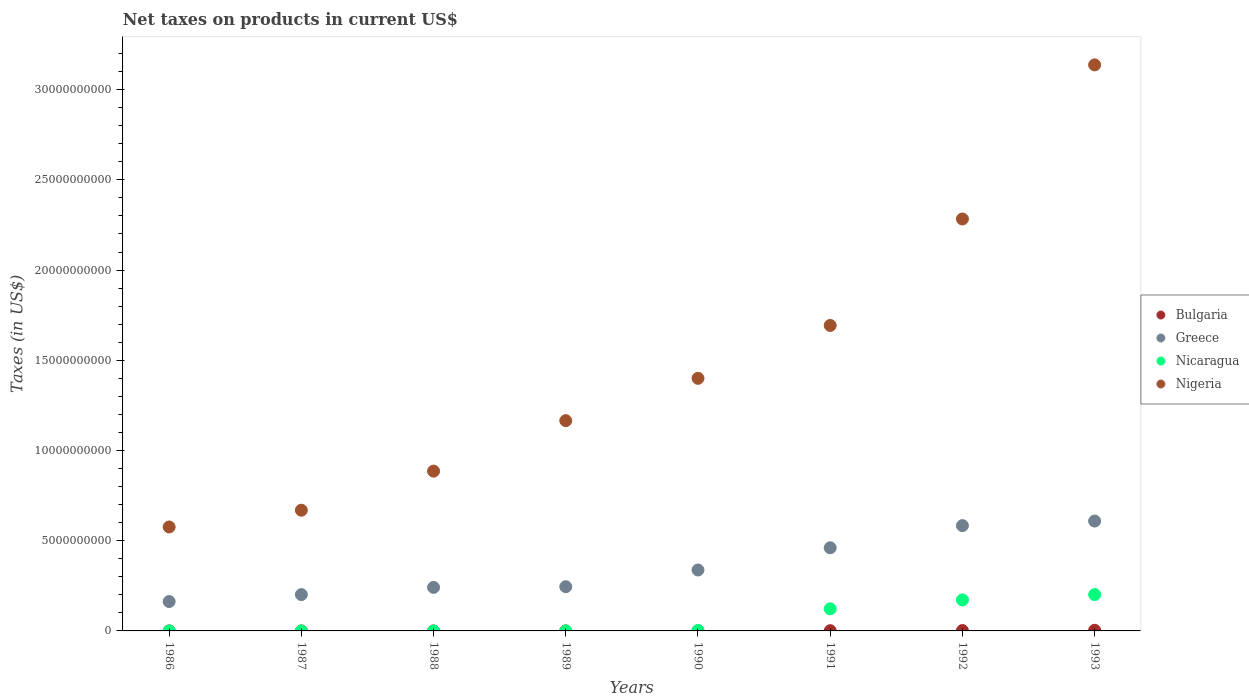How many different coloured dotlines are there?
Offer a terse response. 4. What is the net taxes on products in Nicaragua in 1991?
Provide a short and direct response. 1.23e+09. Across all years, what is the maximum net taxes on products in Nigeria?
Your response must be concise. 3.14e+1. Across all years, what is the minimum net taxes on products in Nigeria?
Offer a terse response. 5.76e+09. In which year was the net taxes on products in Greece maximum?
Your answer should be very brief. 1993. What is the total net taxes on products in Greece in the graph?
Provide a short and direct response. 2.84e+1. What is the difference between the net taxes on products in Nigeria in 1986 and that in 1993?
Give a very brief answer. -2.56e+1. What is the difference between the net taxes on products in Bulgaria in 1993 and the net taxes on products in Nicaragua in 1986?
Your answer should be compact. 3.62e+07. What is the average net taxes on products in Bulgaria per year?
Make the answer very short. 8.72e+06. In the year 1988, what is the difference between the net taxes on products in Nicaragua and net taxes on products in Nigeria?
Your answer should be compact. -8.86e+09. In how many years, is the net taxes on products in Greece greater than 5000000000 US$?
Your answer should be compact. 2. What is the ratio of the net taxes on products in Nigeria in 1988 to that in 1991?
Your answer should be compact. 0.52. Is the net taxes on products in Nigeria in 1988 less than that in 1989?
Give a very brief answer. Yes. Is the difference between the net taxes on products in Nicaragua in 1989 and 1990 greater than the difference between the net taxes on products in Nigeria in 1989 and 1990?
Offer a very short reply. Yes. What is the difference between the highest and the second highest net taxes on products in Greece?
Give a very brief answer. 2.54e+08. What is the difference between the highest and the lowest net taxes on products in Bulgaria?
Your answer should be compact. 3.62e+07. Is it the case that in every year, the sum of the net taxes on products in Nicaragua and net taxes on products in Nigeria  is greater than the net taxes on products in Bulgaria?
Provide a short and direct response. Yes. Is the net taxes on products in Bulgaria strictly greater than the net taxes on products in Nigeria over the years?
Your response must be concise. No. Is the net taxes on products in Nigeria strictly less than the net taxes on products in Nicaragua over the years?
Make the answer very short. No. How many years are there in the graph?
Keep it short and to the point. 8. Are the values on the major ticks of Y-axis written in scientific E-notation?
Keep it short and to the point. No. Does the graph contain grids?
Give a very brief answer. No. How many legend labels are there?
Your answer should be very brief. 4. What is the title of the graph?
Provide a short and direct response. Net taxes on products in current US$. What is the label or title of the X-axis?
Give a very brief answer. Years. What is the label or title of the Y-axis?
Offer a terse response. Taxes (in US$). What is the Taxes (in US$) of Bulgaria in 1986?
Your answer should be very brief. 5.85e+05. What is the Taxes (in US$) in Greece in 1986?
Offer a very short reply. 1.63e+09. What is the Taxes (in US$) of Nicaragua in 1986?
Give a very brief answer. 18.95. What is the Taxes (in US$) of Nigeria in 1986?
Give a very brief answer. 5.76e+09. What is the Taxes (in US$) in Bulgaria in 1987?
Offer a terse response. 0. What is the Taxes (in US$) in Greece in 1987?
Make the answer very short. 2.01e+09. What is the Taxes (in US$) in Nicaragua in 1987?
Keep it short and to the point. 99.43. What is the Taxes (in US$) in Nigeria in 1987?
Make the answer very short. 6.69e+09. What is the Taxes (in US$) in Bulgaria in 1988?
Your response must be concise. 0. What is the Taxes (in US$) in Greece in 1988?
Provide a short and direct response. 2.41e+09. What is the Taxes (in US$) of Nicaragua in 1988?
Your answer should be very brief. 5343.08. What is the Taxes (in US$) in Nigeria in 1988?
Your answer should be very brief. 8.86e+09. What is the Taxes (in US$) of Greece in 1989?
Offer a terse response. 2.45e+09. What is the Taxes (in US$) of Nicaragua in 1989?
Your answer should be compact. 4.98e+05. What is the Taxes (in US$) in Nigeria in 1989?
Your answer should be very brief. 1.17e+1. What is the Taxes (in US$) in Greece in 1990?
Provide a short and direct response. 3.38e+09. What is the Taxes (in US$) in Nicaragua in 1990?
Provide a short and direct response. 2.35e+07. What is the Taxes (in US$) in Nigeria in 1990?
Your answer should be compact. 1.40e+1. What is the Taxes (in US$) of Bulgaria in 1991?
Your response must be concise. 1.24e+07. What is the Taxes (in US$) of Greece in 1991?
Your answer should be very brief. 4.61e+09. What is the Taxes (in US$) in Nicaragua in 1991?
Offer a very short reply. 1.23e+09. What is the Taxes (in US$) in Nigeria in 1991?
Offer a terse response. 1.69e+1. What is the Taxes (in US$) of Bulgaria in 1992?
Make the answer very short. 2.05e+07. What is the Taxes (in US$) of Greece in 1992?
Give a very brief answer. 5.84e+09. What is the Taxes (in US$) in Nicaragua in 1992?
Ensure brevity in your answer.  1.72e+09. What is the Taxes (in US$) in Nigeria in 1992?
Ensure brevity in your answer.  2.28e+1. What is the Taxes (in US$) in Bulgaria in 1993?
Your answer should be compact. 3.62e+07. What is the Taxes (in US$) in Greece in 1993?
Keep it short and to the point. 6.09e+09. What is the Taxes (in US$) in Nicaragua in 1993?
Ensure brevity in your answer.  2.01e+09. What is the Taxes (in US$) of Nigeria in 1993?
Offer a very short reply. 3.14e+1. Across all years, what is the maximum Taxes (in US$) of Bulgaria?
Offer a very short reply. 3.62e+07. Across all years, what is the maximum Taxes (in US$) of Greece?
Offer a very short reply. 6.09e+09. Across all years, what is the maximum Taxes (in US$) in Nicaragua?
Keep it short and to the point. 2.01e+09. Across all years, what is the maximum Taxes (in US$) of Nigeria?
Offer a terse response. 3.14e+1. Across all years, what is the minimum Taxes (in US$) of Greece?
Provide a succinct answer. 1.63e+09. Across all years, what is the minimum Taxes (in US$) of Nicaragua?
Keep it short and to the point. 18.95. Across all years, what is the minimum Taxes (in US$) in Nigeria?
Your response must be concise. 5.76e+09. What is the total Taxes (in US$) in Bulgaria in the graph?
Your answer should be compact. 6.97e+07. What is the total Taxes (in US$) in Greece in the graph?
Your answer should be very brief. 2.84e+1. What is the total Taxes (in US$) of Nicaragua in the graph?
Provide a short and direct response. 4.98e+09. What is the total Taxes (in US$) in Nigeria in the graph?
Make the answer very short. 1.18e+11. What is the difference between the Taxes (in US$) of Greece in 1986 and that in 1987?
Provide a succinct answer. -3.85e+08. What is the difference between the Taxes (in US$) of Nicaragua in 1986 and that in 1987?
Your answer should be compact. -80.48. What is the difference between the Taxes (in US$) of Nigeria in 1986 and that in 1987?
Your answer should be compact. -9.29e+08. What is the difference between the Taxes (in US$) in Greece in 1986 and that in 1988?
Offer a terse response. -7.85e+08. What is the difference between the Taxes (in US$) of Nicaragua in 1986 and that in 1988?
Your answer should be compact. -5324.13. What is the difference between the Taxes (in US$) of Nigeria in 1986 and that in 1988?
Keep it short and to the point. -3.09e+09. What is the difference between the Taxes (in US$) of Greece in 1986 and that in 1989?
Provide a succinct answer. -8.23e+08. What is the difference between the Taxes (in US$) of Nicaragua in 1986 and that in 1989?
Your answer should be very brief. -4.98e+05. What is the difference between the Taxes (in US$) of Nigeria in 1986 and that in 1989?
Offer a very short reply. -5.89e+09. What is the difference between the Taxes (in US$) in Greece in 1986 and that in 1990?
Keep it short and to the point. -1.75e+09. What is the difference between the Taxes (in US$) of Nicaragua in 1986 and that in 1990?
Make the answer very short. -2.35e+07. What is the difference between the Taxes (in US$) in Nigeria in 1986 and that in 1990?
Your answer should be compact. -8.24e+09. What is the difference between the Taxes (in US$) in Bulgaria in 1986 and that in 1991?
Give a very brief answer. -1.19e+07. What is the difference between the Taxes (in US$) of Greece in 1986 and that in 1991?
Ensure brevity in your answer.  -2.98e+09. What is the difference between the Taxes (in US$) of Nicaragua in 1986 and that in 1991?
Your response must be concise. -1.23e+09. What is the difference between the Taxes (in US$) of Nigeria in 1986 and that in 1991?
Keep it short and to the point. -1.12e+1. What is the difference between the Taxes (in US$) of Bulgaria in 1986 and that in 1992?
Keep it short and to the point. -1.99e+07. What is the difference between the Taxes (in US$) in Greece in 1986 and that in 1992?
Offer a terse response. -4.21e+09. What is the difference between the Taxes (in US$) in Nicaragua in 1986 and that in 1992?
Offer a very short reply. -1.72e+09. What is the difference between the Taxes (in US$) of Nigeria in 1986 and that in 1992?
Your response must be concise. -1.71e+1. What is the difference between the Taxes (in US$) in Bulgaria in 1986 and that in 1993?
Offer a terse response. -3.56e+07. What is the difference between the Taxes (in US$) of Greece in 1986 and that in 1993?
Make the answer very short. -4.46e+09. What is the difference between the Taxes (in US$) in Nicaragua in 1986 and that in 1993?
Offer a terse response. -2.01e+09. What is the difference between the Taxes (in US$) of Nigeria in 1986 and that in 1993?
Your answer should be compact. -2.56e+1. What is the difference between the Taxes (in US$) of Greece in 1987 and that in 1988?
Offer a terse response. -4.00e+08. What is the difference between the Taxes (in US$) of Nicaragua in 1987 and that in 1988?
Offer a terse response. -5243.65. What is the difference between the Taxes (in US$) in Nigeria in 1987 and that in 1988?
Give a very brief answer. -2.17e+09. What is the difference between the Taxes (in US$) of Greece in 1987 and that in 1989?
Provide a short and direct response. -4.38e+08. What is the difference between the Taxes (in US$) in Nicaragua in 1987 and that in 1989?
Offer a terse response. -4.98e+05. What is the difference between the Taxes (in US$) of Nigeria in 1987 and that in 1989?
Offer a terse response. -4.96e+09. What is the difference between the Taxes (in US$) of Greece in 1987 and that in 1990?
Keep it short and to the point. -1.36e+09. What is the difference between the Taxes (in US$) in Nicaragua in 1987 and that in 1990?
Offer a very short reply. -2.35e+07. What is the difference between the Taxes (in US$) of Nigeria in 1987 and that in 1990?
Keep it short and to the point. -7.31e+09. What is the difference between the Taxes (in US$) in Greece in 1987 and that in 1991?
Offer a very short reply. -2.59e+09. What is the difference between the Taxes (in US$) in Nicaragua in 1987 and that in 1991?
Offer a very short reply. -1.23e+09. What is the difference between the Taxes (in US$) of Nigeria in 1987 and that in 1991?
Offer a very short reply. -1.02e+1. What is the difference between the Taxes (in US$) in Greece in 1987 and that in 1992?
Your answer should be compact. -3.82e+09. What is the difference between the Taxes (in US$) of Nicaragua in 1987 and that in 1992?
Provide a succinct answer. -1.72e+09. What is the difference between the Taxes (in US$) in Nigeria in 1987 and that in 1992?
Ensure brevity in your answer.  -1.61e+1. What is the difference between the Taxes (in US$) of Greece in 1987 and that in 1993?
Provide a succinct answer. -4.08e+09. What is the difference between the Taxes (in US$) of Nicaragua in 1987 and that in 1993?
Keep it short and to the point. -2.01e+09. What is the difference between the Taxes (in US$) of Nigeria in 1987 and that in 1993?
Your answer should be very brief. -2.47e+1. What is the difference between the Taxes (in US$) of Greece in 1988 and that in 1989?
Offer a terse response. -3.81e+07. What is the difference between the Taxes (in US$) of Nicaragua in 1988 and that in 1989?
Make the answer very short. -4.92e+05. What is the difference between the Taxes (in US$) in Nigeria in 1988 and that in 1989?
Offer a terse response. -2.80e+09. What is the difference between the Taxes (in US$) of Greece in 1988 and that in 1990?
Give a very brief answer. -9.64e+08. What is the difference between the Taxes (in US$) of Nicaragua in 1988 and that in 1990?
Your answer should be compact. -2.35e+07. What is the difference between the Taxes (in US$) in Nigeria in 1988 and that in 1990?
Ensure brevity in your answer.  -5.14e+09. What is the difference between the Taxes (in US$) of Greece in 1988 and that in 1991?
Give a very brief answer. -2.19e+09. What is the difference between the Taxes (in US$) of Nicaragua in 1988 and that in 1991?
Give a very brief answer. -1.23e+09. What is the difference between the Taxes (in US$) in Nigeria in 1988 and that in 1991?
Provide a short and direct response. -8.08e+09. What is the difference between the Taxes (in US$) of Greece in 1988 and that in 1992?
Your answer should be very brief. -3.42e+09. What is the difference between the Taxes (in US$) in Nicaragua in 1988 and that in 1992?
Keep it short and to the point. -1.72e+09. What is the difference between the Taxes (in US$) in Nigeria in 1988 and that in 1992?
Keep it short and to the point. -1.40e+1. What is the difference between the Taxes (in US$) of Greece in 1988 and that in 1993?
Provide a short and direct response. -3.68e+09. What is the difference between the Taxes (in US$) of Nicaragua in 1988 and that in 1993?
Offer a very short reply. -2.01e+09. What is the difference between the Taxes (in US$) of Nigeria in 1988 and that in 1993?
Your response must be concise. -2.25e+1. What is the difference between the Taxes (in US$) in Greece in 1989 and that in 1990?
Your answer should be very brief. -9.26e+08. What is the difference between the Taxes (in US$) of Nicaragua in 1989 and that in 1990?
Keep it short and to the point. -2.30e+07. What is the difference between the Taxes (in US$) in Nigeria in 1989 and that in 1990?
Make the answer very short. -2.35e+09. What is the difference between the Taxes (in US$) in Greece in 1989 and that in 1991?
Your answer should be very brief. -2.16e+09. What is the difference between the Taxes (in US$) in Nicaragua in 1989 and that in 1991?
Ensure brevity in your answer.  -1.23e+09. What is the difference between the Taxes (in US$) in Nigeria in 1989 and that in 1991?
Your answer should be very brief. -5.28e+09. What is the difference between the Taxes (in US$) in Greece in 1989 and that in 1992?
Your response must be concise. -3.38e+09. What is the difference between the Taxes (in US$) of Nicaragua in 1989 and that in 1992?
Give a very brief answer. -1.72e+09. What is the difference between the Taxes (in US$) in Nigeria in 1989 and that in 1992?
Give a very brief answer. -1.12e+1. What is the difference between the Taxes (in US$) of Greece in 1989 and that in 1993?
Your answer should be very brief. -3.64e+09. What is the difference between the Taxes (in US$) in Nicaragua in 1989 and that in 1993?
Provide a short and direct response. -2.01e+09. What is the difference between the Taxes (in US$) of Nigeria in 1989 and that in 1993?
Offer a very short reply. -1.97e+1. What is the difference between the Taxes (in US$) of Greece in 1990 and that in 1991?
Keep it short and to the point. -1.23e+09. What is the difference between the Taxes (in US$) of Nicaragua in 1990 and that in 1991?
Provide a succinct answer. -1.20e+09. What is the difference between the Taxes (in US$) of Nigeria in 1990 and that in 1991?
Keep it short and to the point. -2.93e+09. What is the difference between the Taxes (in US$) of Greece in 1990 and that in 1992?
Make the answer very short. -2.46e+09. What is the difference between the Taxes (in US$) of Nicaragua in 1990 and that in 1992?
Ensure brevity in your answer.  -1.69e+09. What is the difference between the Taxes (in US$) of Nigeria in 1990 and that in 1992?
Your answer should be very brief. -8.83e+09. What is the difference between the Taxes (in US$) in Greece in 1990 and that in 1993?
Keep it short and to the point. -2.71e+09. What is the difference between the Taxes (in US$) in Nicaragua in 1990 and that in 1993?
Provide a short and direct response. -1.99e+09. What is the difference between the Taxes (in US$) in Nigeria in 1990 and that in 1993?
Give a very brief answer. -1.74e+1. What is the difference between the Taxes (in US$) of Bulgaria in 1991 and that in 1992?
Your answer should be very brief. -8.10e+06. What is the difference between the Taxes (in US$) in Greece in 1991 and that in 1992?
Your answer should be very brief. -1.23e+09. What is the difference between the Taxes (in US$) of Nicaragua in 1991 and that in 1992?
Give a very brief answer. -4.92e+08. What is the difference between the Taxes (in US$) in Nigeria in 1991 and that in 1992?
Provide a short and direct response. -5.90e+09. What is the difference between the Taxes (in US$) of Bulgaria in 1991 and that in 1993?
Ensure brevity in your answer.  -2.37e+07. What is the difference between the Taxes (in US$) of Greece in 1991 and that in 1993?
Your response must be concise. -1.48e+09. What is the difference between the Taxes (in US$) in Nicaragua in 1991 and that in 1993?
Offer a very short reply. -7.88e+08. What is the difference between the Taxes (in US$) in Nigeria in 1991 and that in 1993?
Ensure brevity in your answer.  -1.44e+1. What is the difference between the Taxes (in US$) in Bulgaria in 1992 and that in 1993?
Your answer should be very brief. -1.56e+07. What is the difference between the Taxes (in US$) in Greece in 1992 and that in 1993?
Offer a terse response. -2.54e+08. What is the difference between the Taxes (in US$) in Nicaragua in 1992 and that in 1993?
Your response must be concise. -2.96e+08. What is the difference between the Taxes (in US$) in Nigeria in 1992 and that in 1993?
Offer a very short reply. -8.54e+09. What is the difference between the Taxes (in US$) in Bulgaria in 1986 and the Taxes (in US$) in Greece in 1987?
Offer a terse response. -2.01e+09. What is the difference between the Taxes (in US$) of Bulgaria in 1986 and the Taxes (in US$) of Nicaragua in 1987?
Provide a succinct answer. 5.85e+05. What is the difference between the Taxes (in US$) in Bulgaria in 1986 and the Taxes (in US$) in Nigeria in 1987?
Your response must be concise. -6.69e+09. What is the difference between the Taxes (in US$) in Greece in 1986 and the Taxes (in US$) in Nicaragua in 1987?
Provide a short and direct response. 1.63e+09. What is the difference between the Taxes (in US$) in Greece in 1986 and the Taxes (in US$) in Nigeria in 1987?
Offer a very short reply. -5.06e+09. What is the difference between the Taxes (in US$) in Nicaragua in 1986 and the Taxes (in US$) in Nigeria in 1987?
Keep it short and to the point. -6.69e+09. What is the difference between the Taxes (in US$) of Bulgaria in 1986 and the Taxes (in US$) of Greece in 1988?
Make the answer very short. -2.41e+09. What is the difference between the Taxes (in US$) in Bulgaria in 1986 and the Taxes (in US$) in Nicaragua in 1988?
Offer a terse response. 5.80e+05. What is the difference between the Taxes (in US$) of Bulgaria in 1986 and the Taxes (in US$) of Nigeria in 1988?
Your answer should be very brief. -8.86e+09. What is the difference between the Taxes (in US$) of Greece in 1986 and the Taxes (in US$) of Nicaragua in 1988?
Provide a short and direct response. 1.63e+09. What is the difference between the Taxes (in US$) in Greece in 1986 and the Taxes (in US$) in Nigeria in 1988?
Ensure brevity in your answer.  -7.23e+09. What is the difference between the Taxes (in US$) in Nicaragua in 1986 and the Taxes (in US$) in Nigeria in 1988?
Ensure brevity in your answer.  -8.86e+09. What is the difference between the Taxes (in US$) of Bulgaria in 1986 and the Taxes (in US$) of Greece in 1989?
Ensure brevity in your answer.  -2.45e+09. What is the difference between the Taxes (in US$) of Bulgaria in 1986 and the Taxes (in US$) of Nicaragua in 1989?
Ensure brevity in your answer.  8.76e+04. What is the difference between the Taxes (in US$) in Bulgaria in 1986 and the Taxes (in US$) in Nigeria in 1989?
Keep it short and to the point. -1.17e+1. What is the difference between the Taxes (in US$) of Greece in 1986 and the Taxes (in US$) of Nicaragua in 1989?
Your answer should be very brief. 1.63e+09. What is the difference between the Taxes (in US$) of Greece in 1986 and the Taxes (in US$) of Nigeria in 1989?
Give a very brief answer. -1.00e+1. What is the difference between the Taxes (in US$) in Nicaragua in 1986 and the Taxes (in US$) in Nigeria in 1989?
Make the answer very short. -1.17e+1. What is the difference between the Taxes (in US$) of Bulgaria in 1986 and the Taxes (in US$) of Greece in 1990?
Your answer should be compact. -3.38e+09. What is the difference between the Taxes (in US$) of Bulgaria in 1986 and the Taxes (in US$) of Nicaragua in 1990?
Your answer should be compact. -2.29e+07. What is the difference between the Taxes (in US$) of Bulgaria in 1986 and the Taxes (in US$) of Nigeria in 1990?
Keep it short and to the point. -1.40e+1. What is the difference between the Taxes (in US$) in Greece in 1986 and the Taxes (in US$) in Nicaragua in 1990?
Your answer should be very brief. 1.60e+09. What is the difference between the Taxes (in US$) of Greece in 1986 and the Taxes (in US$) of Nigeria in 1990?
Keep it short and to the point. -1.24e+1. What is the difference between the Taxes (in US$) of Nicaragua in 1986 and the Taxes (in US$) of Nigeria in 1990?
Offer a terse response. -1.40e+1. What is the difference between the Taxes (in US$) in Bulgaria in 1986 and the Taxes (in US$) in Greece in 1991?
Ensure brevity in your answer.  -4.61e+09. What is the difference between the Taxes (in US$) in Bulgaria in 1986 and the Taxes (in US$) in Nicaragua in 1991?
Provide a succinct answer. -1.23e+09. What is the difference between the Taxes (in US$) of Bulgaria in 1986 and the Taxes (in US$) of Nigeria in 1991?
Your response must be concise. -1.69e+1. What is the difference between the Taxes (in US$) of Greece in 1986 and the Taxes (in US$) of Nicaragua in 1991?
Your answer should be compact. 4.02e+08. What is the difference between the Taxes (in US$) in Greece in 1986 and the Taxes (in US$) in Nigeria in 1991?
Your response must be concise. -1.53e+1. What is the difference between the Taxes (in US$) of Nicaragua in 1986 and the Taxes (in US$) of Nigeria in 1991?
Provide a short and direct response. -1.69e+1. What is the difference between the Taxes (in US$) of Bulgaria in 1986 and the Taxes (in US$) of Greece in 1992?
Your response must be concise. -5.84e+09. What is the difference between the Taxes (in US$) in Bulgaria in 1986 and the Taxes (in US$) in Nicaragua in 1992?
Ensure brevity in your answer.  -1.72e+09. What is the difference between the Taxes (in US$) of Bulgaria in 1986 and the Taxes (in US$) of Nigeria in 1992?
Make the answer very short. -2.28e+1. What is the difference between the Taxes (in US$) in Greece in 1986 and the Taxes (in US$) in Nicaragua in 1992?
Give a very brief answer. -8.96e+07. What is the difference between the Taxes (in US$) in Greece in 1986 and the Taxes (in US$) in Nigeria in 1992?
Your response must be concise. -2.12e+1. What is the difference between the Taxes (in US$) of Nicaragua in 1986 and the Taxes (in US$) of Nigeria in 1992?
Make the answer very short. -2.28e+1. What is the difference between the Taxes (in US$) in Bulgaria in 1986 and the Taxes (in US$) in Greece in 1993?
Provide a short and direct response. -6.09e+09. What is the difference between the Taxes (in US$) of Bulgaria in 1986 and the Taxes (in US$) of Nicaragua in 1993?
Offer a very short reply. -2.01e+09. What is the difference between the Taxes (in US$) in Bulgaria in 1986 and the Taxes (in US$) in Nigeria in 1993?
Provide a succinct answer. -3.14e+1. What is the difference between the Taxes (in US$) in Greece in 1986 and the Taxes (in US$) in Nicaragua in 1993?
Make the answer very short. -3.86e+08. What is the difference between the Taxes (in US$) of Greece in 1986 and the Taxes (in US$) of Nigeria in 1993?
Your answer should be compact. -2.97e+1. What is the difference between the Taxes (in US$) of Nicaragua in 1986 and the Taxes (in US$) of Nigeria in 1993?
Provide a short and direct response. -3.14e+1. What is the difference between the Taxes (in US$) in Greece in 1987 and the Taxes (in US$) in Nicaragua in 1988?
Your answer should be very brief. 2.01e+09. What is the difference between the Taxes (in US$) of Greece in 1987 and the Taxes (in US$) of Nigeria in 1988?
Provide a succinct answer. -6.84e+09. What is the difference between the Taxes (in US$) of Nicaragua in 1987 and the Taxes (in US$) of Nigeria in 1988?
Give a very brief answer. -8.86e+09. What is the difference between the Taxes (in US$) in Greece in 1987 and the Taxes (in US$) in Nicaragua in 1989?
Offer a terse response. 2.01e+09. What is the difference between the Taxes (in US$) of Greece in 1987 and the Taxes (in US$) of Nigeria in 1989?
Your response must be concise. -9.64e+09. What is the difference between the Taxes (in US$) in Nicaragua in 1987 and the Taxes (in US$) in Nigeria in 1989?
Ensure brevity in your answer.  -1.17e+1. What is the difference between the Taxes (in US$) in Greece in 1987 and the Taxes (in US$) in Nicaragua in 1990?
Ensure brevity in your answer.  1.99e+09. What is the difference between the Taxes (in US$) in Greece in 1987 and the Taxes (in US$) in Nigeria in 1990?
Your answer should be compact. -1.20e+1. What is the difference between the Taxes (in US$) of Nicaragua in 1987 and the Taxes (in US$) of Nigeria in 1990?
Keep it short and to the point. -1.40e+1. What is the difference between the Taxes (in US$) of Greece in 1987 and the Taxes (in US$) of Nicaragua in 1991?
Keep it short and to the point. 7.87e+08. What is the difference between the Taxes (in US$) in Greece in 1987 and the Taxes (in US$) in Nigeria in 1991?
Your answer should be compact. -1.49e+1. What is the difference between the Taxes (in US$) of Nicaragua in 1987 and the Taxes (in US$) of Nigeria in 1991?
Give a very brief answer. -1.69e+1. What is the difference between the Taxes (in US$) in Greece in 1987 and the Taxes (in US$) in Nicaragua in 1992?
Provide a short and direct response. 2.95e+08. What is the difference between the Taxes (in US$) in Greece in 1987 and the Taxes (in US$) in Nigeria in 1992?
Provide a short and direct response. -2.08e+1. What is the difference between the Taxes (in US$) in Nicaragua in 1987 and the Taxes (in US$) in Nigeria in 1992?
Your answer should be compact. -2.28e+1. What is the difference between the Taxes (in US$) of Greece in 1987 and the Taxes (in US$) of Nicaragua in 1993?
Provide a succinct answer. -5.89e+05. What is the difference between the Taxes (in US$) of Greece in 1987 and the Taxes (in US$) of Nigeria in 1993?
Your answer should be very brief. -2.94e+1. What is the difference between the Taxes (in US$) in Nicaragua in 1987 and the Taxes (in US$) in Nigeria in 1993?
Offer a very short reply. -3.14e+1. What is the difference between the Taxes (in US$) of Greece in 1988 and the Taxes (in US$) of Nicaragua in 1989?
Offer a terse response. 2.41e+09. What is the difference between the Taxes (in US$) of Greece in 1988 and the Taxes (in US$) of Nigeria in 1989?
Your response must be concise. -9.24e+09. What is the difference between the Taxes (in US$) in Nicaragua in 1988 and the Taxes (in US$) in Nigeria in 1989?
Your answer should be very brief. -1.17e+1. What is the difference between the Taxes (in US$) of Greece in 1988 and the Taxes (in US$) of Nicaragua in 1990?
Your answer should be very brief. 2.39e+09. What is the difference between the Taxes (in US$) in Greece in 1988 and the Taxes (in US$) in Nigeria in 1990?
Keep it short and to the point. -1.16e+1. What is the difference between the Taxes (in US$) of Nicaragua in 1988 and the Taxes (in US$) of Nigeria in 1990?
Your answer should be compact. -1.40e+1. What is the difference between the Taxes (in US$) in Greece in 1988 and the Taxes (in US$) in Nicaragua in 1991?
Your answer should be very brief. 1.19e+09. What is the difference between the Taxes (in US$) of Greece in 1988 and the Taxes (in US$) of Nigeria in 1991?
Your answer should be very brief. -1.45e+1. What is the difference between the Taxes (in US$) in Nicaragua in 1988 and the Taxes (in US$) in Nigeria in 1991?
Your answer should be compact. -1.69e+1. What is the difference between the Taxes (in US$) in Greece in 1988 and the Taxes (in US$) in Nicaragua in 1992?
Provide a short and direct response. 6.95e+08. What is the difference between the Taxes (in US$) in Greece in 1988 and the Taxes (in US$) in Nigeria in 1992?
Your answer should be very brief. -2.04e+1. What is the difference between the Taxes (in US$) in Nicaragua in 1988 and the Taxes (in US$) in Nigeria in 1992?
Offer a very short reply. -2.28e+1. What is the difference between the Taxes (in US$) in Greece in 1988 and the Taxes (in US$) in Nicaragua in 1993?
Your answer should be compact. 3.99e+08. What is the difference between the Taxes (in US$) of Greece in 1988 and the Taxes (in US$) of Nigeria in 1993?
Ensure brevity in your answer.  -2.90e+1. What is the difference between the Taxes (in US$) of Nicaragua in 1988 and the Taxes (in US$) of Nigeria in 1993?
Your answer should be very brief. -3.14e+1. What is the difference between the Taxes (in US$) in Greece in 1989 and the Taxes (in US$) in Nicaragua in 1990?
Your answer should be compact. 2.43e+09. What is the difference between the Taxes (in US$) in Greece in 1989 and the Taxes (in US$) in Nigeria in 1990?
Offer a very short reply. -1.15e+1. What is the difference between the Taxes (in US$) of Nicaragua in 1989 and the Taxes (in US$) of Nigeria in 1990?
Provide a succinct answer. -1.40e+1. What is the difference between the Taxes (in US$) in Greece in 1989 and the Taxes (in US$) in Nicaragua in 1991?
Your response must be concise. 1.23e+09. What is the difference between the Taxes (in US$) in Greece in 1989 and the Taxes (in US$) in Nigeria in 1991?
Offer a very short reply. -1.45e+1. What is the difference between the Taxes (in US$) in Nicaragua in 1989 and the Taxes (in US$) in Nigeria in 1991?
Keep it short and to the point. -1.69e+1. What is the difference between the Taxes (in US$) of Greece in 1989 and the Taxes (in US$) of Nicaragua in 1992?
Make the answer very short. 7.34e+08. What is the difference between the Taxes (in US$) in Greece in 1989 and the Taxes (in US$) in Nigeria in 1992?
Make the answer very short. -2.04e+1. What is the difference between the Taxes (in US$) in Nicaragua in 1989 and the Taxes (in US$) in Nigeria in 1992?
Offer a very short reply. -2.28e+1. What is the difference between the Taxes (in US$) in Greece in 1989 and the Taxes (in US$) in Nicaragua in 1993?
Give a very brief answer. 4.38e+08. What is the difference between the Taxes (in US$) in Greece in 1989 and the Taxes (in US$) in Nigeria in 1993?
Offer a very short reply. -2.89e+1. What is the difference between the Taxes (in US$) in Nicaragua in 1989 and the Taxes (in US$) in Nigeria in 1993?
Your response must be concise. -3.14e+1. What is the difference between the Taxes (in US$) in Greece in 1990 and the Taxes (in US$) in Nicaragua in 1991?
Provide a succinct answer. 2.15e+09. What is the difference between the Taxes (in US$) of Greece in 1990 and the Taxes (in US$) of Nigeria in 1991?
Make the answer very short. -1.36e+1. What is the difference between the Taxes (in US$) in Nicaragua in 1990 and the Taxes (in US$) in Nigeria in 1991?
Provide a short and direct response. -1.69e+1. What is the difference between the Taxes (in US$) in Greece in 1990 and the Taxes (in US$) in Nicaragua in 1992?
Ensure brevity in your answer.  1.66e+09. What is the difference between the Taxes (in US$) of Greece in 1990 and the Taxes (in US$) of Nigeria in 1992?
Your answer should be compact. -1.95e+1. What is the difference between the Taxes (in US$) in Nicaragua in 1990 and the Taxes (in US$) in Nigeria in 1992?
Offer a very short reply. -2.28e+1. What is the difference between the Taxes (in US$) in Greece in 1990 and the Taxes (in US$) in Nicaragua in 1993?
Offer a very short reply. 1.36e+09. What is the difference between the Taxes (in US$) in Greece in 1990 and the Taxes (in US$) in Nigeria in 1993?
Offer a very short reply. -2.80e+1. What is the difference between the Taxes (in US$) of Nicaragua in 1990 and the Taxes (in US$) of Nigeria in 1993?
Make the answer very short. -3.13e+1. What is the difference between the Taxes (in US$) of Bulgaria in 1991 and the Taxes (in US$) of Greece in 1992?
Give a very brief answer. -5.82e+09. What is the difference between the Taxes (in US$) in Bulgaria in 1991 and the Taxes (in US$) in Nicaragua in 1992?
Your answer should be compact. -1.71e+09. What is the difference between the Taxes (in US$) of Bulgaria in 1991 and the Taxes (in US$) of Nigeria in 1992?
Provide a succinct answer. -2.28e+1. What is the difference between the Taxes (in US$) in Greece in 1991 and the Taxes (in US$) in Nicaragua in 1992?
Provide a succinct answer. 2.89e+09. What is the difference between the Taxes (in US$) in Greece in 1991 and the Taxes (in US$) in Nigeria in 1992?
Your response must be concise. -1.82e+1. What is the difference between the Taxes (in US$) in Nicaragua in 1991 and the Taxes (in US$) in Nigeria in 1992?
Provide a short and direct response. -2.16e+1. What is the difference between the Taxes (in US$) of Bulgaria in 1991 and the Taxes (in US$) of Greece in 1993?
Offer a very short reply. -6.08e+09. What is the difference between the Taxes (in US$) in Bulgaria in 1991 and the Taxes (in US$) in Nicaragua in 1993?
Keep it short and to the point. -2.00e+09. What is the difference between the Taxes (in US$) in Bulgaria in 1991 and the Taxes (in US$) in Nigeria in 1993?
Your answer should be very brief. -3.14e+1. What is the difference between the Taxes (in US$) in Greece in 1991 and the Taxes (in US$) in Nicaragua in 1993?
Keep it short and to the point. 2.59e+09. What is the difference between the Taxes (in US$) of Greece in 1991 and the Taxes (in US$) of Nigeria in 1993?
Provide a succinct answer. -2.68e+1. What is the difference between the Taxes (in US$) of Nicaragua in 1991 and the Taxes (in US$) of Nigeria in 1993?
Provide a short and direct response. -3.01e+1. What is the difference between the Taxes (in US$) of Bulgaria in 1992 and the Taxes (in US$) of Greece in 1993?
Make the answer very short. -6.07e+09. What is the difference between the Taxes (in US$) in Bulgaria in 1992 and the Taxes (in US$) in Nicaragua in 1993?
Your answer should be very brief. -1.99e+09. What is the difference between the Taxes (in US$) of Bulgaria in 1992 and the Taxes (in US$) of Nigeria in 1993?
Your response must be concise. -3.14e+1. What is the difference between the Taxes (in US$) of Greece in 1992 and the Taxes (in US$) of Nicaragua in 1993?
Give a very brief answer. 3.82e+09. What is the difference between the Taxes (in US$) in Greece in 1992 and the Taxes (in US$) in Nigeria in 1993?
Your response must be concise. -2.55e+1. What is the difference between the Taxes (in US$) in Nicaragua in 1992 and the Taxes (in US$) in Nigeria in 1993?
Your answer should be very brief. -2.97e+1. What is the average Taxes (in US$) in Bulgaria per year?
Offer a very short reply. 8.72e+06. What is the average Taxes (in US$) in Greece per year?
Give a very brief answer. 3.55e+09. What is the average Taxes (in US$) in Nicaragua per year?
Your response must be concise. 6.23e+08. What is the average Taxes (in US$) of Nigeria per year?
Your answer should be very brief. 1.48e+1. In the year 1986, what is the difference between the Taxes (in US$) of Bulgaria and Taxes (in US$) of Greece?
Give a very brief answer. -1.63e+09. In the year 1986, what is the difference between the Taxes (in US$) of Bulgaria and Taxes (in US$) of Nicaragua?
Provide a short and direct response. 5.85e+05. In the year 1986, what is the difference between the Taxes (in US$) in Bulgaria and Taxes (in US$) in Nigeria?
Offer a very short reply. -5.76e+09. In the year 1986, what is the difference between the Taxes (in US$) of Greece and Taxes (in US$) of Nicaragua?
Provide a short and direct response. 1.63e+09. In the year 1986, what is the difference between the Taxes (in US$) in Greece and Taxes (in US$) in Nigeria?
Ensure brevity in your answer.  -4.13e+09. In the year 1986, what is the difference between the Taxes (in US$) in Nicaragua and Taxes (in US$) in Nigeria?
Ensure brevity in your answer.  -5.76e+09. In the year 1987, what is the difference between the Taxes (in US$) in Greece and Taxes (in US$) in Nicaragua?
Your answer should be very brief. 2.01e+09. In the year 1987, what is the difference between the Taxes (in US$) in Greece and Taxes (in US$) in Nigeria?
Give a very brief answer. -4.68e+09. In the year 1987, what is the difference between the Taxes (in US$) in Nicaragua and Taxes (in US$) in Nigeria?
Give a very brief answer. -6.69e+09. In the year 1988, what is the difference between the Taxes (in US$) in Greece and Taxes (in US$) in Nicaragua?
Make the answer very short. 2.41e+09. In the year 1988, what is the difference between the Taxes (in US$) of Greece and Taxes (in US$) of Nigeria?
Your answer should be very brief. -6.44e+09. In the year 1988, what is the difference between the Taxes (in US$) of Nicaragua and Taxes (in US$) of Nigeria?
Give a very brief answer. -8.86e+09. In the year 1989, what is the difference between the Taxes (in US$) of Greece and Taxes (in US$) of Nicaragua?
Offer a terse response. 2.45e+09. In the year 1989, what is the difference between the Taxes (in US$) in Greece and Taxes (in US$) in Nigeria?
Ensure brevity in your answer.  -9.20e+09. In the year 1989, what is the difference between the Taxes (in US$) in Nicaragua and Taxes (in US$) in Nigeria?
Your answer should be compact. -1.17e+1. In the year 1990, what is the difference between the Taxes (in US$) of Greece and Taxes (in US$) of Nicaragua?
Give a very brief answer. 3.35e+09. In the year 1990, what is the difference between the Taxes (in US$) of Greece and Taxes (in US$) of Nigeria?
Offer a terse response. -1.06e+1. In the year 1990, what is the difference between the Taxes (in US$) in Nicaragua and Taxes (in US$) in Nigeria?
Your answer should be compact. -1.40e+1. In the year 1991, what is the difference between the Taxes (in US$) in Bulgaria and Taxes (in US$) in Greece?
Give a very brief answer. -4.60e+09. In the year 1991, what is the difference between the Taxes (in US$) of Bulgaria and Taxes (in US$) of Nicaragua?
Provide a succinct answer. -1.21e+09. In the year 1991, what is the difference between the Taxes (in US$) of Bulgaria and Taxes (in US$) of Nigeria?
Provide a short and direct response. -1.69e+1. In the year 1991, what is the difference between the Taxes (in US$) in Greece and Taxes (in US$) in Nicaragua?
Provide a succinct answer. 3.38e+09. In the year 1991, what is the difference between the Taxes (in US$) in Greece and Taxes (in US$) in Nigeria?
Ensure brevity in your answer.  -1.23e+1. In the year 1991, what is the difference between the Taxes (in US$) of Nicaragua and Taxes (in US$) of Nigeria?
Make the answer very short. -1.57e+1. In the year 1992, what is the difference between the Taxes (in US$) of Bulgaria and Taxes (in US$) of Greece?
Ensure brevity in your answer.  -5.82e+09. In the year 1992, what is the difference between the Taxes (in US$) of Bulgaria and Taxes (in US$) of Nicaragua?
Provide a short and direct response. -1.70e+09. In the year 1992, what is the difference between the Taxes (in US$) of Bulgaria and Taxes (in US$) of Nigeria?
Offer a terse response. -2.28e+1. In the year 1992, what is the difference between the Taxes (in US$) in Greece and Taxes (in US$) in Nicaragua?
Keep it short and to the point. 4.12e+09. In the year 1992, what is the difference between the Taxes (in US$) of Greece and Taxes (in US$) of Nigeria?
Provide a short and direct response. -1.70e+1. In the year 1992, what is the difference between the Taxes (in US$) in Nicaragua and Taxes (in US$) in Nigeria?
Offer a very short reply. -2.11e+1. In the year 1993, what is the difference between the Taxes (in US$) of Bulgaria and Taxes (in US$) of Greece?
Your answer should be very brief. -6.05e+09. In the year 1993, what is the difference between the Taxes (in US$) of Bulgaria and Taxes (in US$) of Nicaragua?
Your response must be concise. -1.98e+09. In the year 1993, what is the difference between the Taxes (in US$) of Bulgaria and Taxes (in US$) of Nigeria?
Your response must be concise. -3.13e+1. In the year 1993, what is the difference between the Taxes (in US$) of Greece and Taxes (in US$) of Nicaragua?
Keep it short and to the point. 4.08e+09. In the year 1993, what is the difference between the Taxes (in US$) in Greece and Taxes (in US$) in Nigeria?
Provide a short and direct response. -2.53e+1. In the year 1993, what is the difference between the Taxes (in US$) in Nicaragua and Taxes (in US$) in Nigeria?
Give a very brief answer. -2.94e+1. What is the ratio of the Taxes (in US$) in Greece in 1986 to that in 1987?
Provide a succinct answer. 0.81. What is the ratio of the Taxes (in US$) of Nicaragua in 1986 to that in 1987?
Offer a very short reply. 0.19. What is the ratio of the Taxes (in US$) of Nigeria in 1986 to that in 1987?
Give a very brief answer. 0.86. What is the ratio of the Taxes (in US$) in Greece in 1986 to that in 1988?
Your answer should be compact. 0.67. What is the ratio of the Taxes (in US$) in Nicaragua in 1986 to that in 1988?
Your answer should be compact. 0. What is the ratio of the Taxes (in US$) in Nigeria in 1986 to that in 1988?
Keep it short and to the point. 0.65. What is the ratio of the Taxes (in US$) in Greece in 1986 to that in 1989?
Keep it short and to the point. 0.66. What is the ratio of the Taxes (in US$) of Nigeria in 1986 to that in 1989?
Your answer should be very brief. 0.49. What is the ratio of the Taxes (in US$) of Greece in 1986 to that in 1990?
Keep it short and to the point. 0.48. What is the ratio of the Taxes (in US$) in Nicaragua in 1986 to that in 1990?
Provide a succinct answer. 0. What is the ratio of the Taxes (in US$) of Nigeria in 1986 to that in 1990?
Your response must be concise. 0.41. What is the ratio of the Taxes (in US$) of Bulgaria in 1986 to that in 1991?
Make the answer very short. 0.05. What is the ratio of the Taxes (in US$) in Greece in 1986 to that in 1991?
Your answer should be very brief. 0.35. What is the ratio of the Taxes (in US$) of Nigeria in 1986 to that in 1991?
Your response must be concise. 0.34. What is the ratio of the Taxes (in US$) in Bulgaria in 1986 to that in 1992?
Provide a short and direct response. 0.03. What is the ratio of the Taxes (in US$) of Greece in 1986 to that in 1992?
Your answer should be compact. 0.28. What is the ratio of the Taxes (in US$) of Nigeria in 1986 to that in 1992?
Make the answer very short. 0.25. What is the ratio of the Taxes (in US$) of Bulgaria in 1986 to that in 1993?
Provide a short and direct response. 0.02. What is the ratio of the Taxes (in US$) of Greece in 1986 to that in 1993?
Keep it short and to the point. 0.27. What is the ratio of the Taxes (in US$) in Nicaragua in 1986 to that in 1993?
Ensure brevity in your answer.  0. What is the ratio of the Taxes (in US$) in Nigeria in 1986 to that in 1993?
Offer a very short reply. 0.18. What is the ratio of the Taxes (in US$) of Greece in 1987 to that in 1988?
Ensure brevity in your answer.  0.83. What is the ratio of the Taxes (in US$) in Nicaragua in 1987 to that in 1988?
Give a very brief answer. 0.02. What is the ratio of the Taxes (in US$) of Nigeria in 1987 to that in 1988?
Make the answer very short. 0.76. What is the ratio of the Taxes (in US$) of Greece in 1987 to that in 1989?
Provide a short and direct response. 0.82. What is the ratio of the Taxes (in US$) of Nicaragua in 1987 to that in 1989?
Your response must be concise. 0. What is the ratio of the Taxes (in US$) of Nigeria in 1987 to that in 1989?
Provide a short and direct response. 0.57. What is the ratio of the Taxes (in US$) in Greece in 1987 to that in 1990?
Give a very brief answer. 0.6. What is the ratio of the Taxes (in US$) in Nicaragua in 1987 to that in 1990?
Ensure brevity in your answer.  0. What is the ratio of the Taxes (in US$) of Nigeria in 1987 to that in 1990?
Make the answer very short. 0.48. What is the ratio of the Taxes (in US$) of Greece in 1987 to that in 1991?
Your response must be concise. 0.44. What is the ratio of the Taxes (in US$) of Nigeria in 1987 to that in 1991?
Keep it short and to the point. 0.4. What is the ratio of the Taxes (in US$) in Greece in 1987 to that in 1992?
Give a very brief answer. 0.34. What is the ratio of the Taxes (in US$) in Nicaragua in 1987 to that in 1992?
Give a very brief answer. 0. What is the ratio of the Taxes (in US$) of Nigeria in 1987 to that in 1992?
Offer a very short reply. 0.29. What is the ratio of the Taxes (in US$) of Greece in 1987 to that in 1993?
Provide a succinct answer. 0.33. What is the ratio of the Taxes (in US$) in Nigeria in 1987 to that in 1993?
Your response must be concise. 0.21. What is the ratio of the Taxes (in US$) in Greece in 1988 to that in 1989?
Your answer should be compact. 0.98. What is the ratio of the Taxes (in US$) in Nicaragua in 1988 to that in 1989?
Offer a terse response. 0.01. What is the ratio of the Taxes (in US$) of Nigeria in 1988 to that in 1989?
Ensure brevity in your answer.  0.76. What is the ratio of the Taxes (in US$) in Greece in 1988 to that in 1990?
Provide a succinct answer. 0.71. What is the ratio of the Taxes (in US$) of Nigeria in 1988 to that in 1990?
Your answer should be very brief. 0.63. What is the ratio of the Taxes (in US$) in Greece in 1988 to that in 1991?
Give a very brief answer. 0.52. What is the ratio of the Taxes (in US$) of Nigeria in 1988 to that in 1991?
Your answer should be very brief. 0.52. What is the ratio of the Taxes (in US$) of Greece in 1988 to that in 1992?
Provide a succinct answer. 0.41. What is the ratio of the Taxes (in US$) of Nigeria in 1988 to that in 1992?
Give a very brief answer. 0.39. What is the ratio of the Taxes (in US$) in Greece in 1988 to that in 1993?
Provide a succinct answer. 0.4. What is the ratio of the Taxes (in US$) of Nigeria in 1988 to that in 1993?
Offer a terse response. 0.28. What is the ratio of the Taxes (in US$) of Greece in 1989 to that in 1990?
Keep it short and to the point. 0.73. What is the ratio of the Taxes (in US$) of Nicaragua in 1989 to that in 1990?
Offer a terse response. 0.02. What is the ratio of the Taxes (in US$) in Nigeria in 1989 to that in 1990?
Offer a terse response. 0.83. What is the ratio of the Taxes (in US$) in Greece in 1989 to that in 1991?
Offer a very short reply. 0.53. What is the ratio of the Taxes (in US$) of Nigeria in 1989 to that in 1991?
Your answer should be compact. 0.69. What is the ratio of the Taxes (in US$) in Greece in 1989 to that in 1992?
Offer a very short reply. 0.42. What is the ratio of the Taxes (in US$) in Nigeria in 1989 to that in 1992?
Provide a succinct answer. 0.51. What is the ratio of the Taxes (in US$) of Greece in 1989 to that in 1993?
Give a very brief answer. 0.4. What is the ratio of the Taxes (in US$) of Nigeria in 1989 to that in 1993?
Your answer should be very brief. 0.37. What is the ratio of the Taxes (in US$) in Greece in 1990 to that in 1991?
Ensure brevity in your answer.  0.73. What is the ratio of the Taxes (in US$) in Nicaragua in 1990 to that in 1991?
Ensure brevity in your answer.  0.02. What is the ratio of the Taxes (in US$) of Nigeria in 1990 to that in 1991?
Your answer should be compact. 0.83. What is the ratio of the Taxes (in US$) of Greece in 1990 to that in 1992?
Offer a terse response. 0.58. What is the ratio of the Taxes (in US$) of Nicaragua in 1990 to that in 1992?
Give a very brief answer. 0.01. What is the ratio of the Taxes (in US$) of Nigeria in 1990 to that in 1992?
Your answer should be very brief. 0.61. What is the ratio of the Taxes (in US$) in Greece in 1990 to that in 1993?
Provide a short and direct response. 0.55. What is the ratio of the Taxes (in US$) in Nicaragua in 1990 to that in 1993?
Your answer should be compact. 0.01. What is the ratio of the Taxes (in US$) in Nigeria in 1990 to that in 1993?
Your response must be concise. 0.45. What is the ratio of the Taxes (in US$) in Bulgaria in 1991 to that in 1992?
Keep it short and to the point. 0.61. What is the ratio of the Taxes (in US$) of Greece in 1991 to that in 1992?
Your response must be concise. 0.79. What is the ratio of the Taxes (in US$) of Nicaragua in 1991 to that in 1992?
Provide a succinct answer. 0.71. What is the ratio of the Taxes (in US$) of Nigeria in 1991 to that in 1992?
Provide a short and direct response. 0.74. What is the ratio of the Taxes (in US$) of Bulgaria in 1991 to that in 1993?
Offer a very short reply. 0.34. What is the ratio of the Taxes (in US$) in Greece in 1991 to that in 1993?
Your response must be concise. 0.76. What is the ratio of the Taxes (in US$) in Nicaragua in 1991 to that in 1993?
Provide a short and direct response. 0.61. What is the ratio of the Taxes (in US$) in Nigeria in 1991 to that in 1993?
Provide a short and direct response. 0.54. What is the ratio of the Taxes (in US$) of Bulgaria in 1992 to that in 1993?
Your answer should be compact. 0.57. What is the ratio of the Taxes (in US$) in Greece in 1992 to that in 1993?
Your answer should be very brief. 0.96. What is the ratio of the Taxes (in US$) of Nicaragua in 1992 to that in 1993?
Give a very brief answer. 0.85. What is the ratio of the Taxes (in US$) in Nigeria in 1992 to that in 1993?
Provide a succinct answer. 0.73. What is the difference between the highest and the second highest Taxes (in US$) of Bulgaria?
Your answer should be compact. 1.56e+07. What is the difference between the highest and the second highest Taxes (in US$) of Greece?
Make the answer very short. 2.54e+08. What is the difference between the highest and the second highest Taxes (in US$) in Nicaragua?
Keep it short and to the point. 2.96e+08. What is the difference between the highest and the second highest Taxes (in US$) of Nigeria?
Keep it short and to the point. 8.54e+09. What is the difference between the highest and the lowest Taxes (in US$) of Bulgaria?
Keep it short and to the point. 3.62e+07. What is the difference between the highest and the lowest Taxes (in US$) of Greece?
Provide a short and direct response. 4.46e+09. What is the difference between the highest and the lowest Taxes (in US$) of Nicaragua?
Offer a terse response. 2.01e+09. What is the difference between the highest and the lowest Taxes (in US$) in Nigeria?
Offer a very short reply. 2.56e+1. 